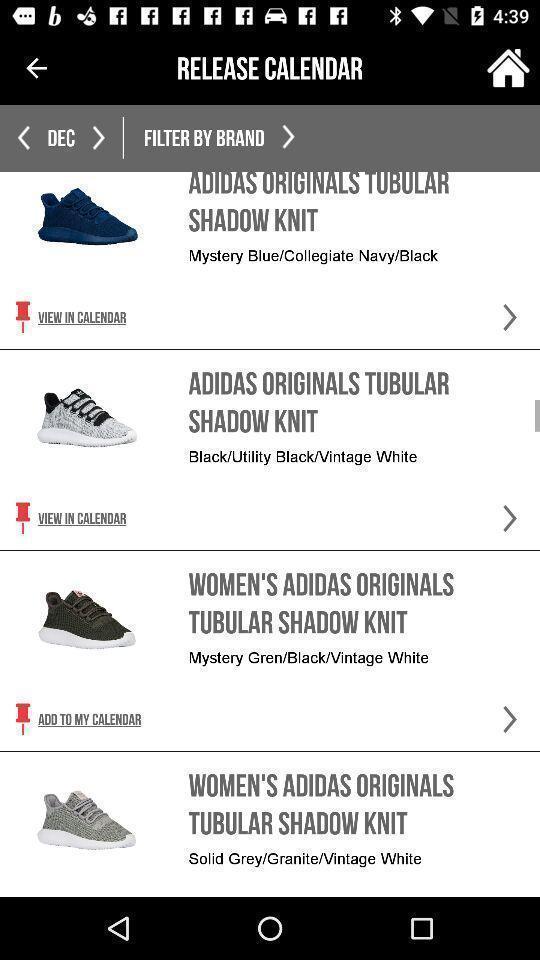Summarize the main components in this picture. Screen showing list of various shoes in a shopping app. 